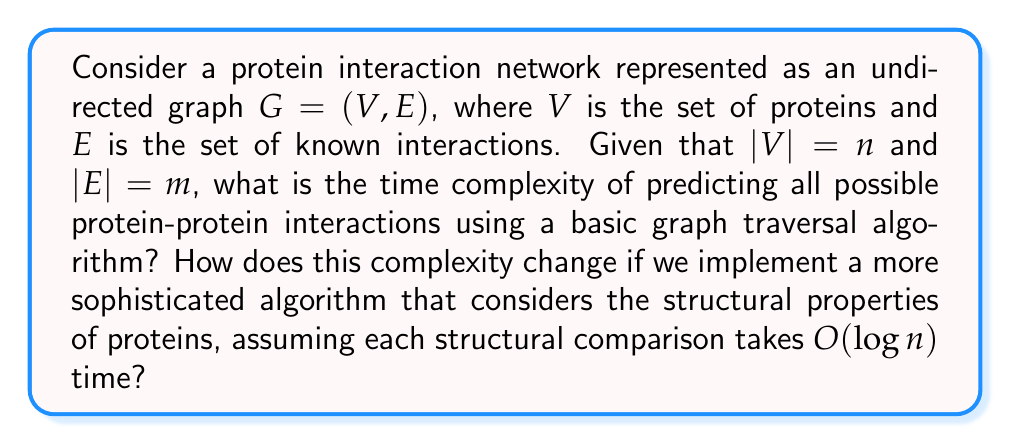Provide a solution to this math problem. To solve this problem, we need to consider the following steps:

1. Basic graph traversal algorithm:
   - For each pair of proteins, we need to check if an edge exists between them.
   - There are $\binom{n}{2} = \frac{n(n-1)}{2}$ possible pairs of proteins.
   - Checking if an edge exists between two vertices in an undirected graph typically takes $O(1)$ time if using an adjacency matrix, or $O(\log m)$ time if using an adjacency list with binary search.
   - Therefore, the time complexity for the basic algorithm is $O(n^2)$ using an adjacency matrix, or $O(n^2 \log m)$ using an adjacency list.

2. Sophisticated algorithm considering structural properties:
   - We still need to check all $\binom{n}{2}$ pairs of proteins.
   - For each pair, we now perform a structural comparison taking $O(\log n)$ time.
   - The total time complexity becomes $O(n^2 \log n)$.

3. Comparison of complexities:
   - Basic algorithm: $O(n^2)$ or $O(n^2 \log m)$
   - Sophisticated algorithm: $O(n^2 \log n)$

   Since $m \leq \binom{n}{2} = O(n^2)$, we have $\log m = O(\log n)$. Therefore, the sophisticated algorithm has a higher time complexity by a factor of $\log n$.

4. Tractability assessment:
   - Both algorithms have polynomial time complexity, which is generally considered tractable.
   - However, for large protein interaction networks (large $n$), the quadratic growth in both algorithms can become computationally expensive.
   - The sophisticated algorithm, while more accurate, comes at the cost of increased time complexity.
Answer: The time complexity for the basic graph traversal algorithm is $O(n^2)$ using an adjacency matrix or $O(n^2 \log m)$ using an adjacency list. The sophisticated algorithm considering structural properties has a time complexity of $O(n^2 \log n)$. Both algorithms are tractable (polynomial time) but may become computationally expensive for large protein interaction networks. 